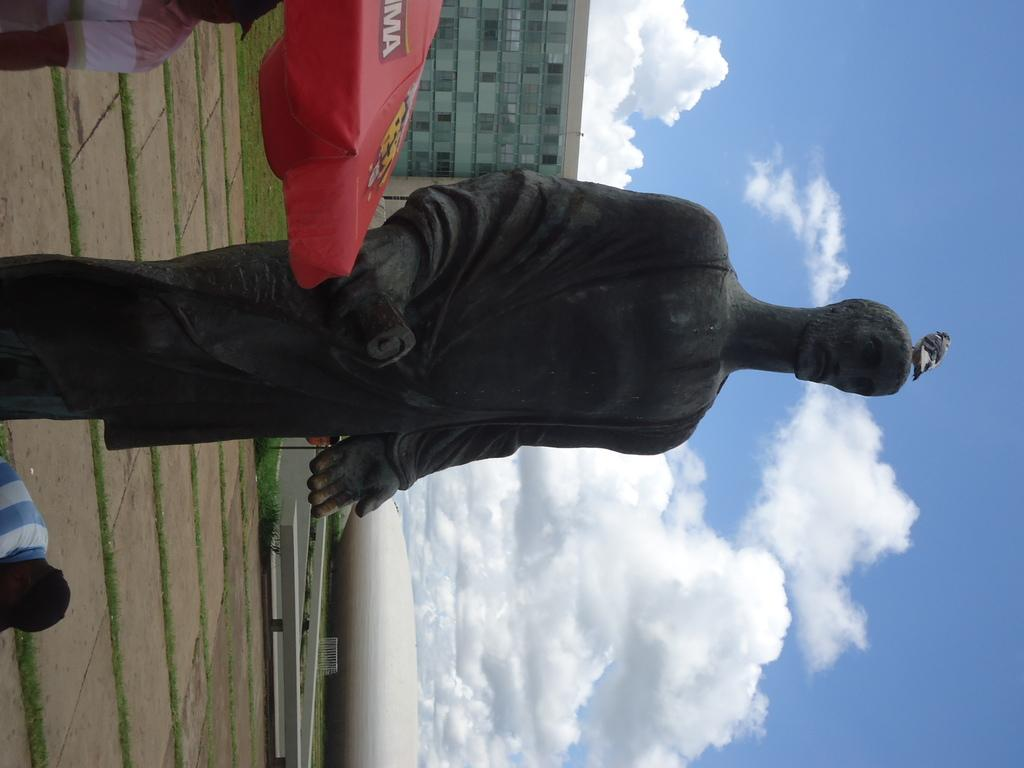What is the main subject in the picture? There is a statue in the picture. What is the ground made of in the picture? There is green grass in the picture. What type of structures can be seen in the background? There are buildings visible in the picture. What is visible in the sky in the picture? Clouds are present in the sky in the picture. What type of beef is being discovered in the memory of the statue in the picture? There is no beef or memory present in the image; it features a statue, green grass, buildings, and clouds in the sky. 